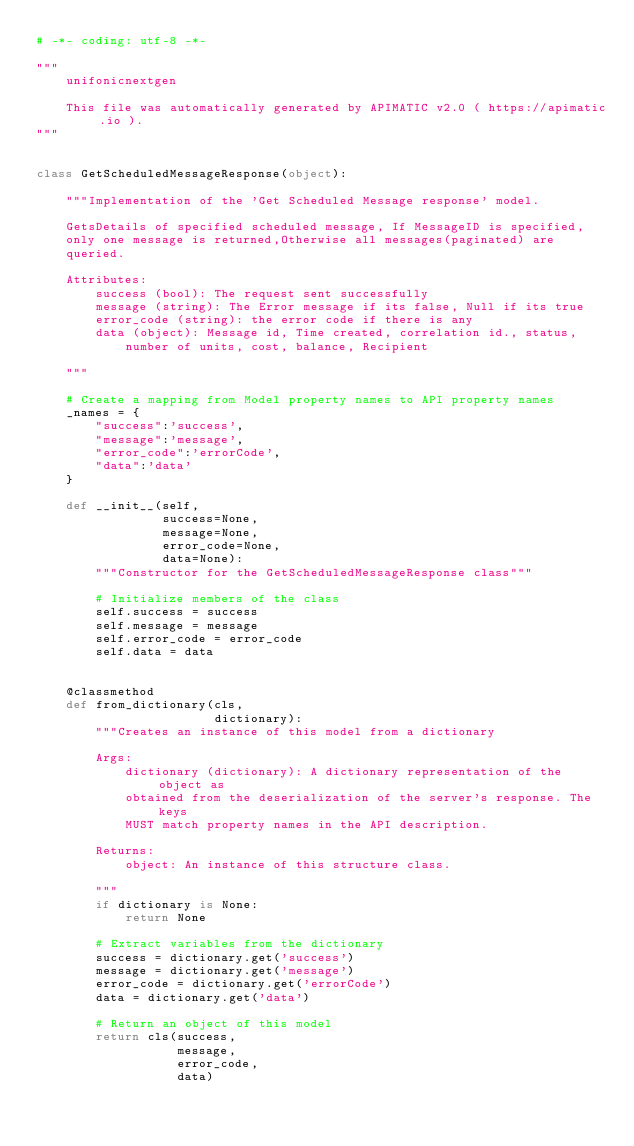Convert code to text. <code><loc_0><loc_0><loc_500><loc_500><_Python_># -*- coding: utf-8 -*-

"""
    unifonicnextgen

    This file was automatically generated by APIMATIC v2.0 ( https://apimatic.io ).
"""


class GetScheduledMessageResponse(object):

    """Implementation of the 'Get Scheduled Message response' model.

    GetsDetails of specified scheduled message, If MessageID is specified,
    only one message is returned,Otherwise all messages(paginated) are
    queried.

    Attributes:
        success (bool): The request sent successfully
        message (string): The Error message if its false, Null if its true
        error_code (string): the error code if there is any
        data (object): Message id, Time created, correlation id., status,
            number of units, cost, balance, Recipient

    """

    # Create a mapping from Model property names to API property names
    _names = {
        "success":'success',
        "message":'message',
        "error_code":'errorCode',
        "data":'data'
    }

    def __init__(self,
                 success=None,
                 message=None,
                 error_code=None,
                 data=None):
        """Constructor for the GetScheduledMessageResponse class"""

        # Initialize members of the class
        self.success = success
        self.message = message
        self.error_code = error_code
        self.data = data


    @classmethod
    def from_dictionary(cls,
                        dictionary):
        """Creates an instance of this model from a dictionary

        Args:
            dictionary (dictionary): A dictionary representation of the object as
            obtained from the deserialization of the server's response. The keys
            MUST match property names in the API description.

        Returns:
            object: An instance of this structure class.

        """
        if dictionary is None:
            return None

        # Extract variables from the dictionary
        success = dictionary.get('success')
        message = dictionary.get('message')
        error_code = dictionary.get('errorCode')
        data = dictionary.get('data')

        # Return an object of this model
        return cls(success,
                   message,
                   error_code,
                   data)


</code> 